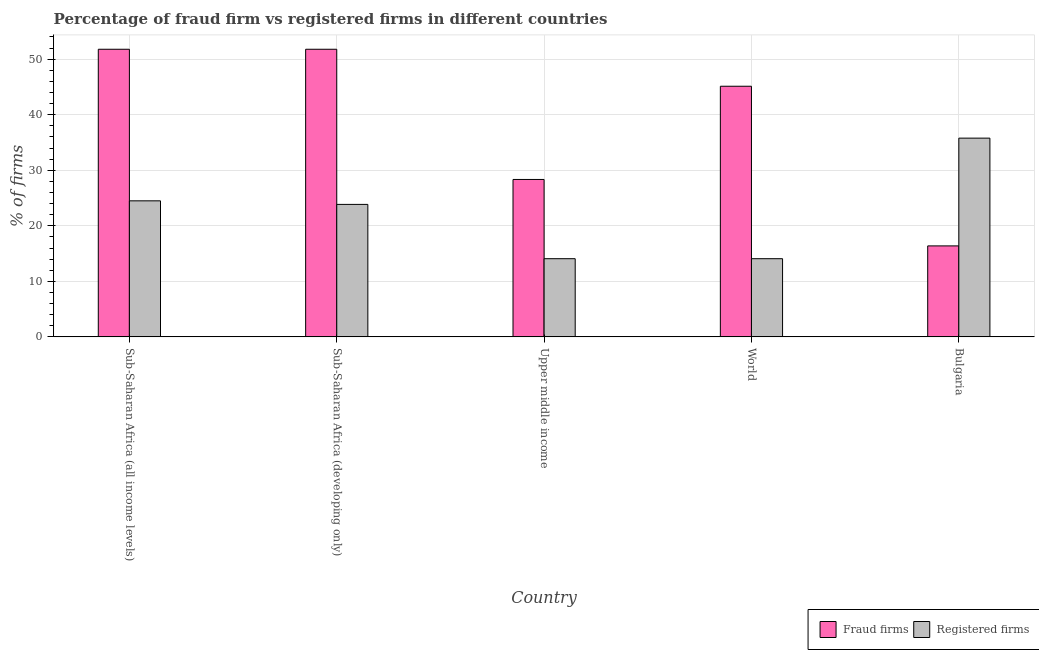How many different coloured bars are there?
Offer a terse response. 2. What is the percentage of fraud firms in Upper middle income?
Your answer should be very brief. 28.34. Across all countries, what is the maximum percentage of fraud firms?
Ensure brevity in your answer.  51.78. Across all countries, what is the minimum percentage of registered firms?
Make the answer very short. 14.07. In which country was the percentage of fraud firms maximum?
Your answer should be compact. Sub-Saharan Africa (all income levels). In which country was the percentage of registered firms minimum?
Keep it short and to the point. Upper middle income. What is the total percentage of fraud firms in the graph?
Offer a very short reply. 193.41. What is the difference between the percentage of fraud firms in Bulgaria and that in Sub-Saharan Africa (all income levels)?
Ensure brevity in your answer.  -35.4. What is the difference between the percentage of fraud firms in Bulgaria and the percentage of registered firms in Sub-Saharan Africa (developing only)?
Offer a terse response. -7.47. What is the average percentage of fraud firms per country?
Ensure brevity in your answer.  38.68. What is the difference between the percentage of fraud firms and percentage of registered firms in Sub-Saharan Africa (developing only)?
Give a very brief answer. 27.93. In how many countries, is the percentage of fraud firms greater than 42 %?
Your response must be concise. 3. What is the ratio of the percentage of fraud firms in Sub-Saharan Africa (all income levels) to that in World?
Ensure brevity in your answer.  1.15. Is the percentage of registered firms in Sub-Saharan Africa (all income levels) less than that in Sub-Saharan Africa (developing only)?
Your response must be concise. No. Is the difference between the percentage of registered firms in Sub-Saharan Africa (all income levels) and Upper middle income greater than the difference between the percentage of fraud firms in Sub-Saharan Africa (all income levels) and Upper middle income?
Your answer should be very brief. No. What is the difference between the highest and the second highest percentage of registered firms?
Give a very brief answer. 11.29. What is the difference between the highest and the lowest percentage of registered firms?
Offer a terse response. 21.71. Is the sum of the percentage of registered firms in Bulgaria and Sub-Saharan Africa (all income levels) greater than the maximum percentage of fraud firms across all countries?
Provide a succinct answer. Yes. What does the 1st bar from the left in Sub-Saharan Africa (developing only) represents?
Your answer should be very brief. Fraud firms. What does the 1st bar from the right in Sub-Saharan Africa (developing only) represents?
Your response must be concise. Registered firms. Where does the legend appear in the graph?
Give a very brief answer. Bottom right. How are the legend labels stacked?
Your answer should be compact. Horizontal. What is the title of the graph?
Your response must be concise. Percentage of fraud firm vs registered firms in different countries. What is the label or title of the Y-axis?
Your response must be concise. % of firms. What is the % of firms of Fraud firms in Sub-Saharan Africa (all income levels)?
Provide a succinct answer. 51.78. What is the % of firms in Registered firms in Sub-Saharan Africa (all income levels)?
Your answer should be compact. 24.49. What is the % of firms in Fraud firms in Sub-Saharan Africa (developing only)?
Keep it short and to the point. 51.78. What is the % of firms of Registered firms in Sub-Saharan Africa (developing only)?
Your answer should be very brief. 23.85. What is the % of firms in Fraud firms in Upper middle income?
Make the answer very short. 28.34. What is the % of firms of Registered firms in Upper middle income?
Ensure brevity in your answer.  14.07. What is the % of firms in Fraud firms in World?
Give a very brief answer. 45.12. What is the % of firms in Registered firms in World?
Make the answer very short. 14.07. What is the % of firms in Fraud firms in Bulgaria?
Ensure brevity in your answer.  16.38. What is the % of firms in Registered firms in Bulgaria?
Offer a terse response. 35.78. Across all countries, what is the maximum % of firms in Fraud firms?
Keep it short and to the point. 51.78. Across all countries, what is the maximum % of firms in Registered firms?
Your response must be concise. 35.78. Across all countries, what is the minimum % of firms in Fraud firms?
Offer a terse response. 16.38. Across all countries, what is the minimum % of firms of Registered firms?
Your response must be concise. 14.07. What is the total % of firms of Fraud firms in the graph?
Ensure brevity in your answer.  193.41. What is the total % of firms of Registered firms in the graph?
Keep it short and to the point. 112.27. What is the difference between the % of firms of Fraud firms in Sub-Saharan Africa (all income levels) and that in Sub-Saharan Africa (developing only)?
Keep it short and to the point. 0. What is the difference between the % of firms in Registered firms in Sub-Saharan Africa (all income levels) and that in Sub-Saharan Africa (developing only)?
Your answer should be very brief. 0.64. What is the difference between the % of firms in Fraud firms in Sub-Saharan Africa (all income levels) and that in Upper middle income?
Your answer should be very brief. 23.44. What is the difference between the % of firms in Registered firms in Sub-Saharan Africa (all income levels) and that in Upper middle income?
Offer a terse response. 10.42. What is the difference between the % of firms in Fraud firms in Sub-Saharan Africa (all income levels) and that in World?
Your answer should be compact. 6.66. What is the difference between the % of firms in Registered firms in Sub-Saharan Africa (all income levels) and that in World?
Your answer should be very brief. 10.42. What is the difference between the % of firms in Fraud firms in Sub-Saharan Africa (all income levels) and that in Bulgaria?
Make the answer very short. 35.4. What is the difference between the % of firms of Registered firms in Sub-Saharan Africa (all income levels) and that in Bulgaria?
Give a very brief answer. -11.29. What is the difference between the % of firms of Fraud firms in Sub-Saharan Africa (developing only) and that in Upper middle income?
Your response must be concise. 23.44. What is the difference between the % of firms in Registered firms in Sub-Saharan Africa (developing only) and that in Upper middle income?
Your answer should be very brief. 9.78. What is the difference between the % of firms of Fraud firms in Sub-Saharan Africa (developing only) and that in World?
Your answer should be very brief. 6.66. What is the difference between the % of firms in Registered firms in Sub-Saharan Africa (developing only) and that in World?
Your response must be concise. 9.78. What is the difference between the % of firms in Fraud firms in Sub-Saharan Africa (developing only) and that in Bulgaria?
Provide a short and direct response. 35.4. What is the difference between the % of firms of Registered firms in Sub-Saharan Africa (developing only) and that in Bulgaria?
Keep it short and to the point. -11.93. What is the difference between the % of firms in Fraud firms in Upper middle income and that in World?
Your answer should be very brief. -16.78. What is the difference between the % of firms in Fraud firms in Upper middle income and that in Bulgaria?
Your answer should be very brief. 11.96. What is the difference between the % of firms of Registered firms in Upper middle income and that in Bulgaria?
Make the answer very short. -21.7. What is the difference between the % of firms in Fraud firms in World and that in Bulgaria?
Offer a very short reply. 28.74. What is the difference between the % of firms of Registered firms in World and that in Bulgaria?
Give a very brief answer. -21.7. What is the difference between the % of firms of Fraud firms in Sub-Saharan Africa (all income levels) and the % of firms of Registered firms in Sub-Saharan Africa (developing only)?
Your answer should be very brief. 27.93. What is the difference between the % of firms in Fraud firms in Sub-Saharan Africa (all income levels) and the % of firms in Registered firms in Upper middle income?
Your answer should be compact. 37.71. What is the difference between the % of firms of Fraud firms in Sub-Saharan Africa (all income levels) and the % of firms of Registered firms in World?
Keep it short and to the point. 37.71. What is the difference between the % of firms in Fraud firms in Sub-Saharan Africa (all income levels) and the % of firms in Registered firms in Bulgaria?
Your response must be concise. 16. What is the difference between the % of firms in Fraud firms in Sub-Saharan Africa (developing only) and the % of firms in Registered firms in Upper middle income?
Provide a short and direct response. 37.71. What is the difference between the % of firms in Fraud firms in Sub-Saharan Africa (developing only) and the % of firms in Registered firms in World?
Ensure brevity in your answer.  37.71. What is the difference between the % of firms of Fraud firms in Sub-Saharan Africa (developing only) and the % of firms of Registered firms in Bulgaria?
Offer a very short reply. 16. What is the difference between the % of firms in Fraud firms in Upper middle income and the % of firms in Registered firms in World?
Your answer should be very brief. 14.27. What is the difference between the % of firms of Fraud firms in Upper middle income and the % of firms of Registered firms in Bulgaria?
Your answer should be compact. -7.44. What is the difference between the % of firms in Fraud firms in World and the % of firms in Registered firms in Bulgaria?
Offer a very short reply. 9.34. What is the average % of firms in Fraud firms per country?
Offer a very short reply. 38.68. What is the average % of firms of Registered firms per country?
Your answer should be compact. 22.45. What is the difference between the % of firms of Fraud firms and % of firms of Registered firms in Sub-Saharan Africa (all income levels)?
Keep it short and to the point. 27.29. What is the difference between the % of firms in Fraud firms and % of firms in Registered firms in Sub-Saharan Africa (developing only)?
Make the answer very short. 27.93. What is the difference between the % of firms in Fraud firms and % of firms in Registered firms in Upper middle income?
Your response must be concise. 14.27. What is the difference between the % of firms of Fraud firms and % of firms of Registered firms in World?
Provide a succinct answer. 31.05. What is the difference between the % of firms of Fraud firms and % of firms of Registered firms in Bulgaria?
Provide a short and direct response. -19.4. What is the ratio of the % of firms in Fraud firms in Sub-Saharan Africa (all income levels) to that in Sub-Saharan Africa (developing only)?
Your response must be concise. 1. What is the ratio of the % of firms in Fraud firms in Sub-Saharan Africa (all income levels) to that in Upper middle income?
Ensure brevity in your answer.  1.83. What is the ratio of the % of firms of Registered firms in Sub-Saharan Africa (all income levels) to that in Upper middle income?
Make the answer very short. 1.74. What is the ratio of the % of firms in Fraud firms in Sub-Saharan Africa (all income levels) to that in World?
Provide a short and direct response. 1.15. What is the ratio of the % of firms of Registered firms in Sub-Saharan Africa (all income levels) to that in World?
Offer a very short reply. 1.74. What is the ratio of the % of firms in Fraud firms in Sub-Saharan Africa (all income levels) to that in Bulgaria?
Your answer should be very brief. 3.16. What is the ratio of the % of firms of Registered firms in Sub-Saharan Africa (all income levels) to that in Bulgaria?
Give a very brief answer. 0.68. What is the ratio of the % of firms in Fraud firms in Sub-Saharan Africa (developing only) to that in Upper middle income?
Keep it short and to the point. 1.83. What is the ratio of the % of firms in Registered firms in Sub-Saharan Africa (developing only) to that in Upper middle income?
Ensure brevity in your answer.  1.69. What is the ratio of the % of firms of Fraud firms in Sub-Saharan Africa (developing only) to that in World?
Offer a very short reply. 1.15. What is the ratio of the % of firms in Registered firms in Sub-Saharan Africa (developing only) to that in World?
Your answer should be very brief. 1.69. What is the ratio of the % of firms of Fraud firms in Sub-Saharan Africa (developing only) to that in Bulgaria?
Provide a succinct answer. 3.16. What is the ratio of the % of firms of Registered firms in Sub-Saharan Africa (developing only) to that in Bulgaria?
Your response must be concise. 0.67. What is the ratio of the % of firms of Fraud firms in Upper middle income to that in World?
Provide a short and direct response. 0.63. What is the ratio of the % of firms of Fraud firms in Upper middle income to that in Bulgaria?
Provide a short and direct response. 1.73. What is the ratio of the % of firms in Registered firms in Upper middle income to that in Bulgaria?
Give a very brief answer. 0.39. What is the ratio of the % of firms of Fraud firms in World to that in Bulgaria?
Make the answer very short. 2.75. What is the ratio of the % of firms in Registered firms in World to that in Bulgaria?
Your answer should be very brief. 0.39. What is the difference between the highest and the second highest % of firms of Fraud firms?
Provide a short and direct response. 0. What is the difference between the highest and the second highest % of firms in Registered firms?
Give a very brief answer. 11.29. What is the difference between the highest and the lowest % of firms in Fraud firms?
Give a very brief answer. 35.4. What is the difference between the highest and the lowest % of firms in Registered firms?
Provide a succinct answer. 21.7. 